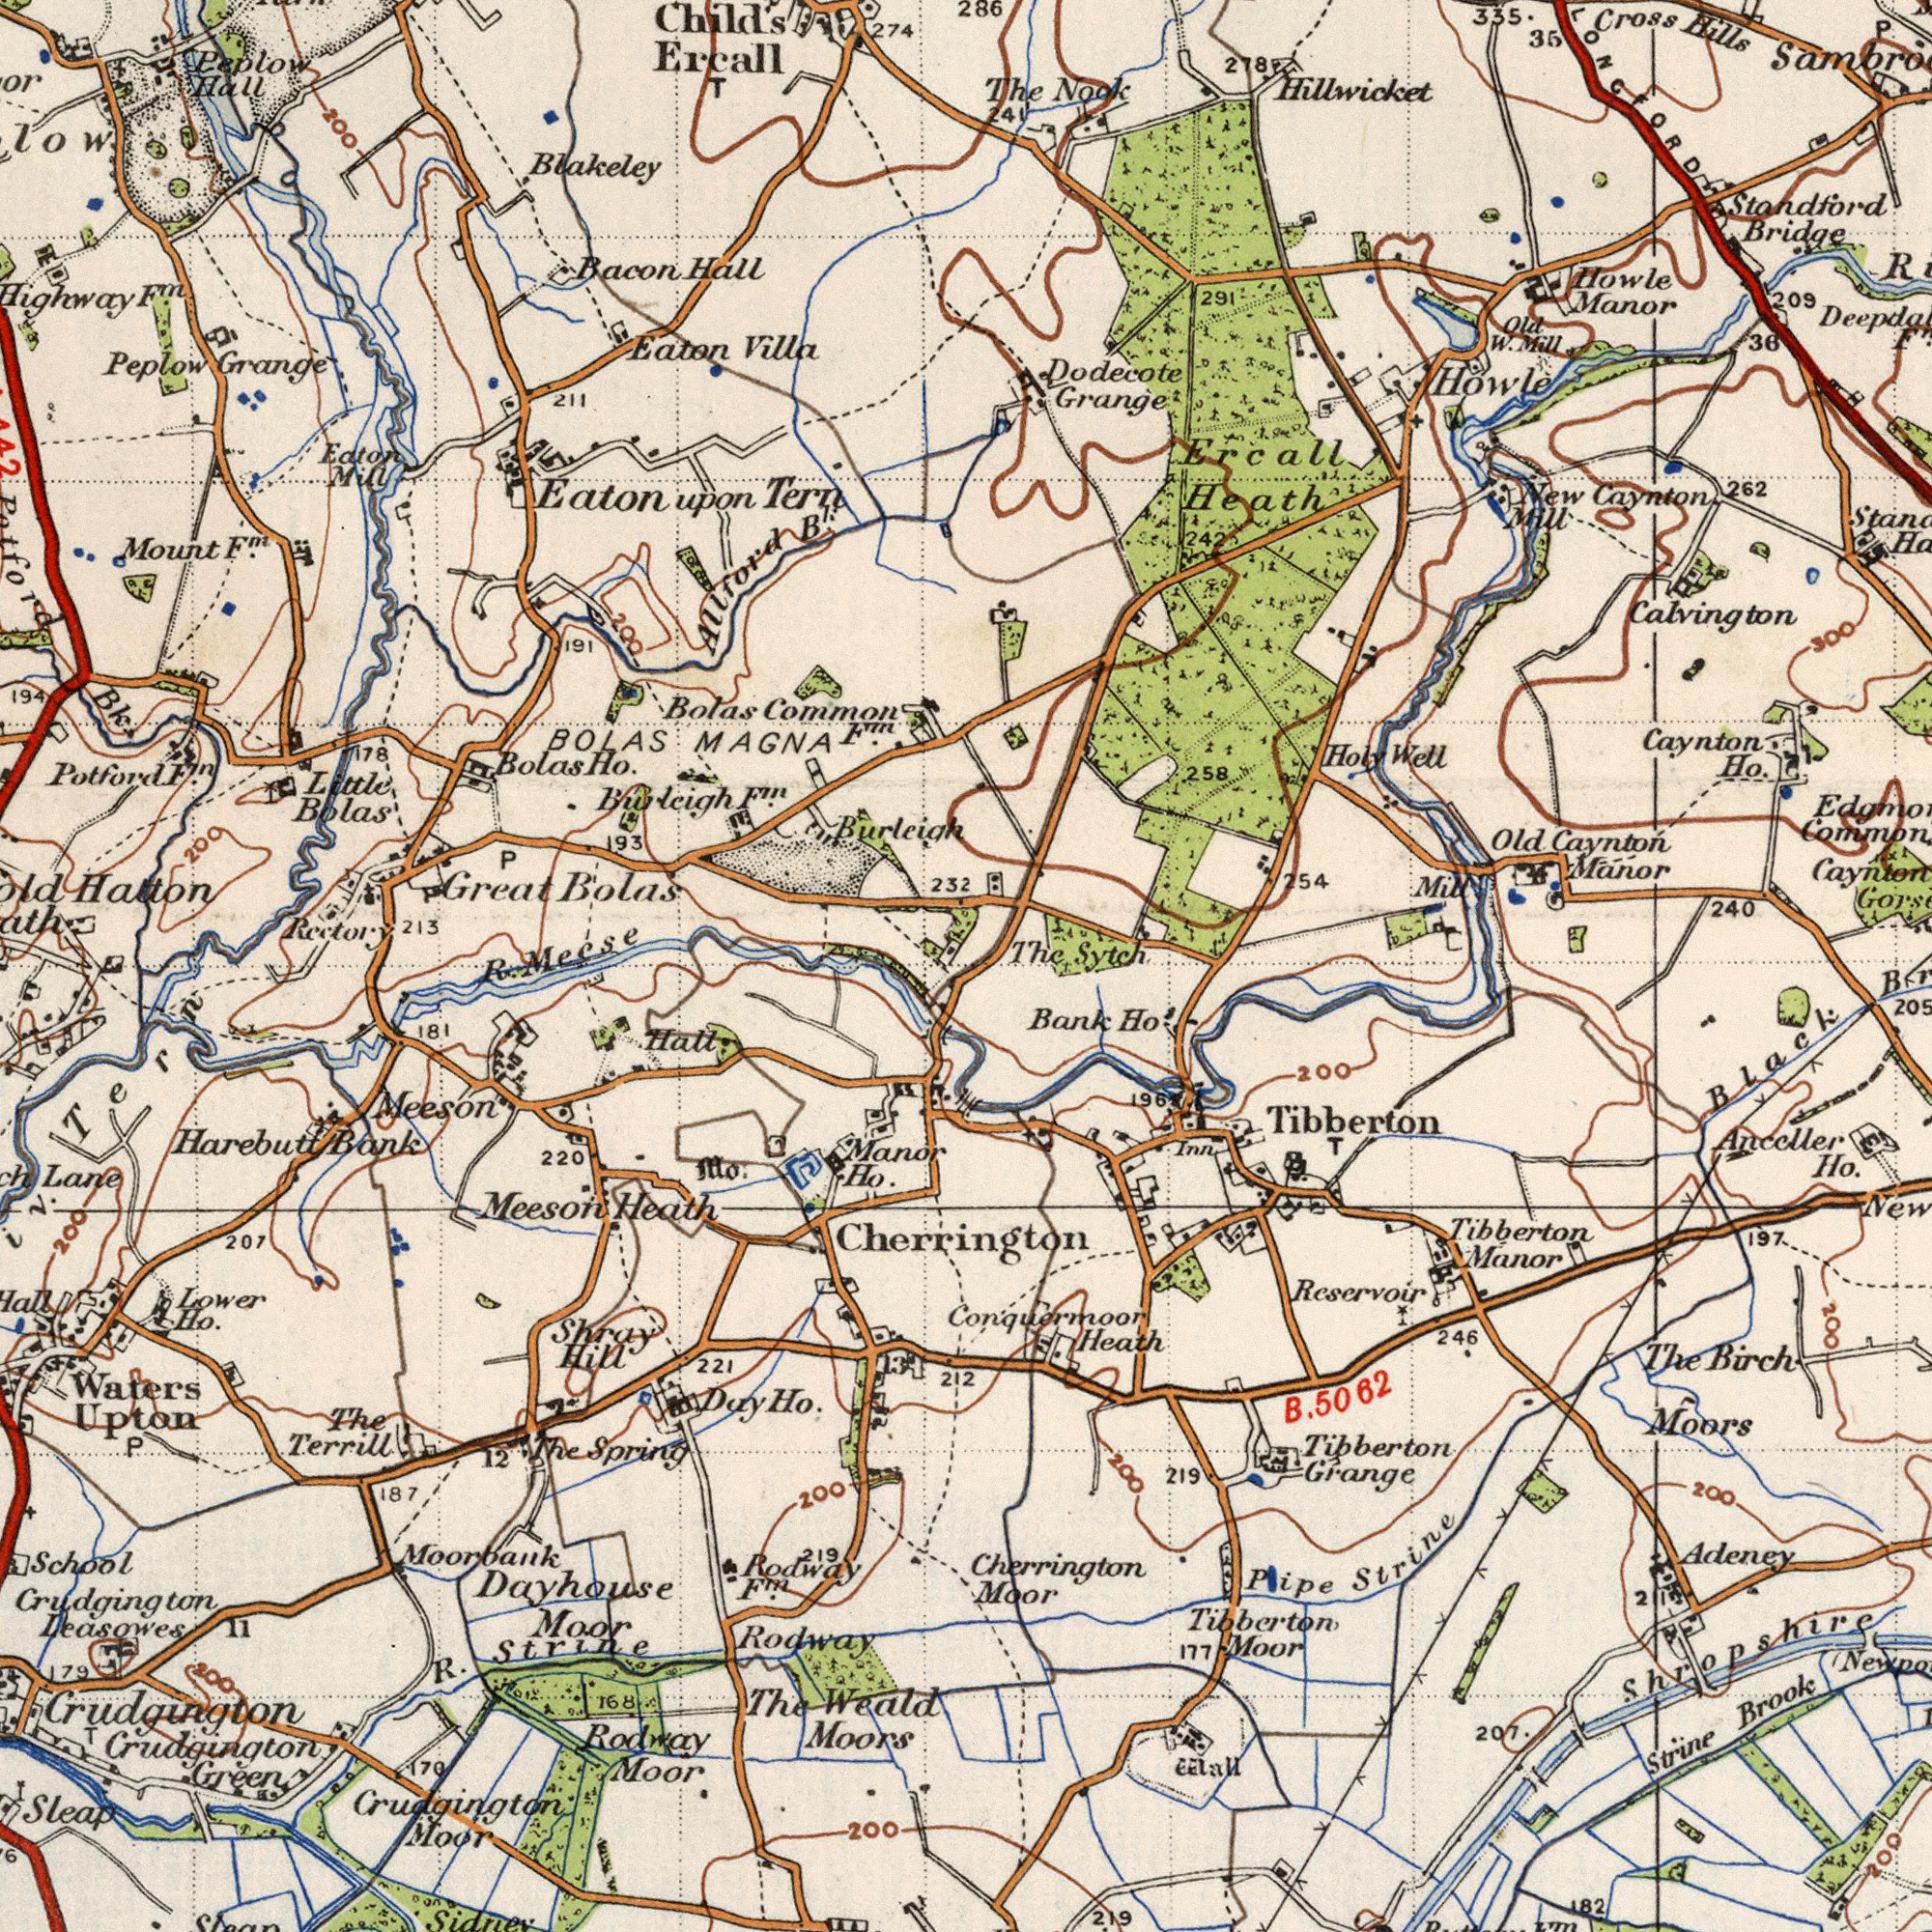What text can you see in the top-left section? Bolas Hall Burleigh Bacon Hatton Eaton Mount Ercall B<sup>l</sup>. BOLAS Peplow Eaton Common Bolas Villa Bolas Potford Great Hall Bk. Mecse Tern Grange Bolas MAGNA 193 Burleigh Ho. 274 Mill Blakeley Eaton 232 178 Rectory Little Allford 213 194 191 211 Child's Peplow F<sup>m</sup>. T 200 P F<sup>m</sup>. 200 F<sup>m</sup>. F<sup>m</sup>. 200 F<sup>m</sup>. E upon What text is shown in the bottom-right quadrant? Cherrington Cherrington Heath Ho. Tibberton Bank Moors Manor Tibberton Rcservoir Grange Tibberton Birch Moor Brook The ###lall 207. Moor Strine Black Strine 197 5062 219 246 Tibberton 219 Anceller 182 200 Inn Adeney Pipe Ho'. 200 211 200 T 200 Conquermoor 196 177 Shropshire E B. 200 What text appears in the top-right area of the image? Heath Cross Calvington Howle Dodecote Howle Bridge Mill 335. 254 Nook The Manor Old Manor Caynton Caynton Hills 240 Caynton Sytch Grange 36 262 209 Well Old The Hillwicket Ho. Holy Ercall 291 Mill Standford 241 35 New P. Mill W. 300 286 278 258 242 What text is visible in the lower-left corner? Dayhouse Meeson Rodway Waters Moors Weald Moor Harebutt Sleap Rodway Spring Upton Bank School Ho. Meeson Leasowes Hill Hall. The Manor The R. Rodway Lower 12 Shray Crudgington 200 Terrill Moorbank 221 Moor 207 220 200 Lane 179 187 Sidnev Ho. Mo. Ho. Crudgington F<sup>m</sup>. 170 11 P Heath Crudgington Day 212 181 Tern Green Strine Moor Crudgington 168 200 219 200 3 The R. T 